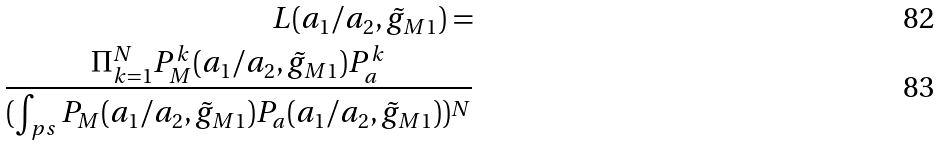Convert formula to latex. <formula><loc_0><loc_0><loc_500><loc_500>L ( a _ { 1 } / a _ { 2 } , \tilde { g } _ { M 1 } ) = \\ \frac { \Pi ^ { N } _ { k = 1 } P ^ { k } _ { M } ( a _ { 1 } / a _ { 2 } , \tilde { g } _ { M 1 } ) P ^ { k } _ { a } } { ( \int _ { p s } P _ { M } ( a _ { 1 } / a _ { 2 } , \tilde { g } _ { M 1 } ) P _ { a } ( a _ { 1 } / a _ { 2 } , \tilde { g } _ { M 1 } ) ) ^ { N } }</formula> 